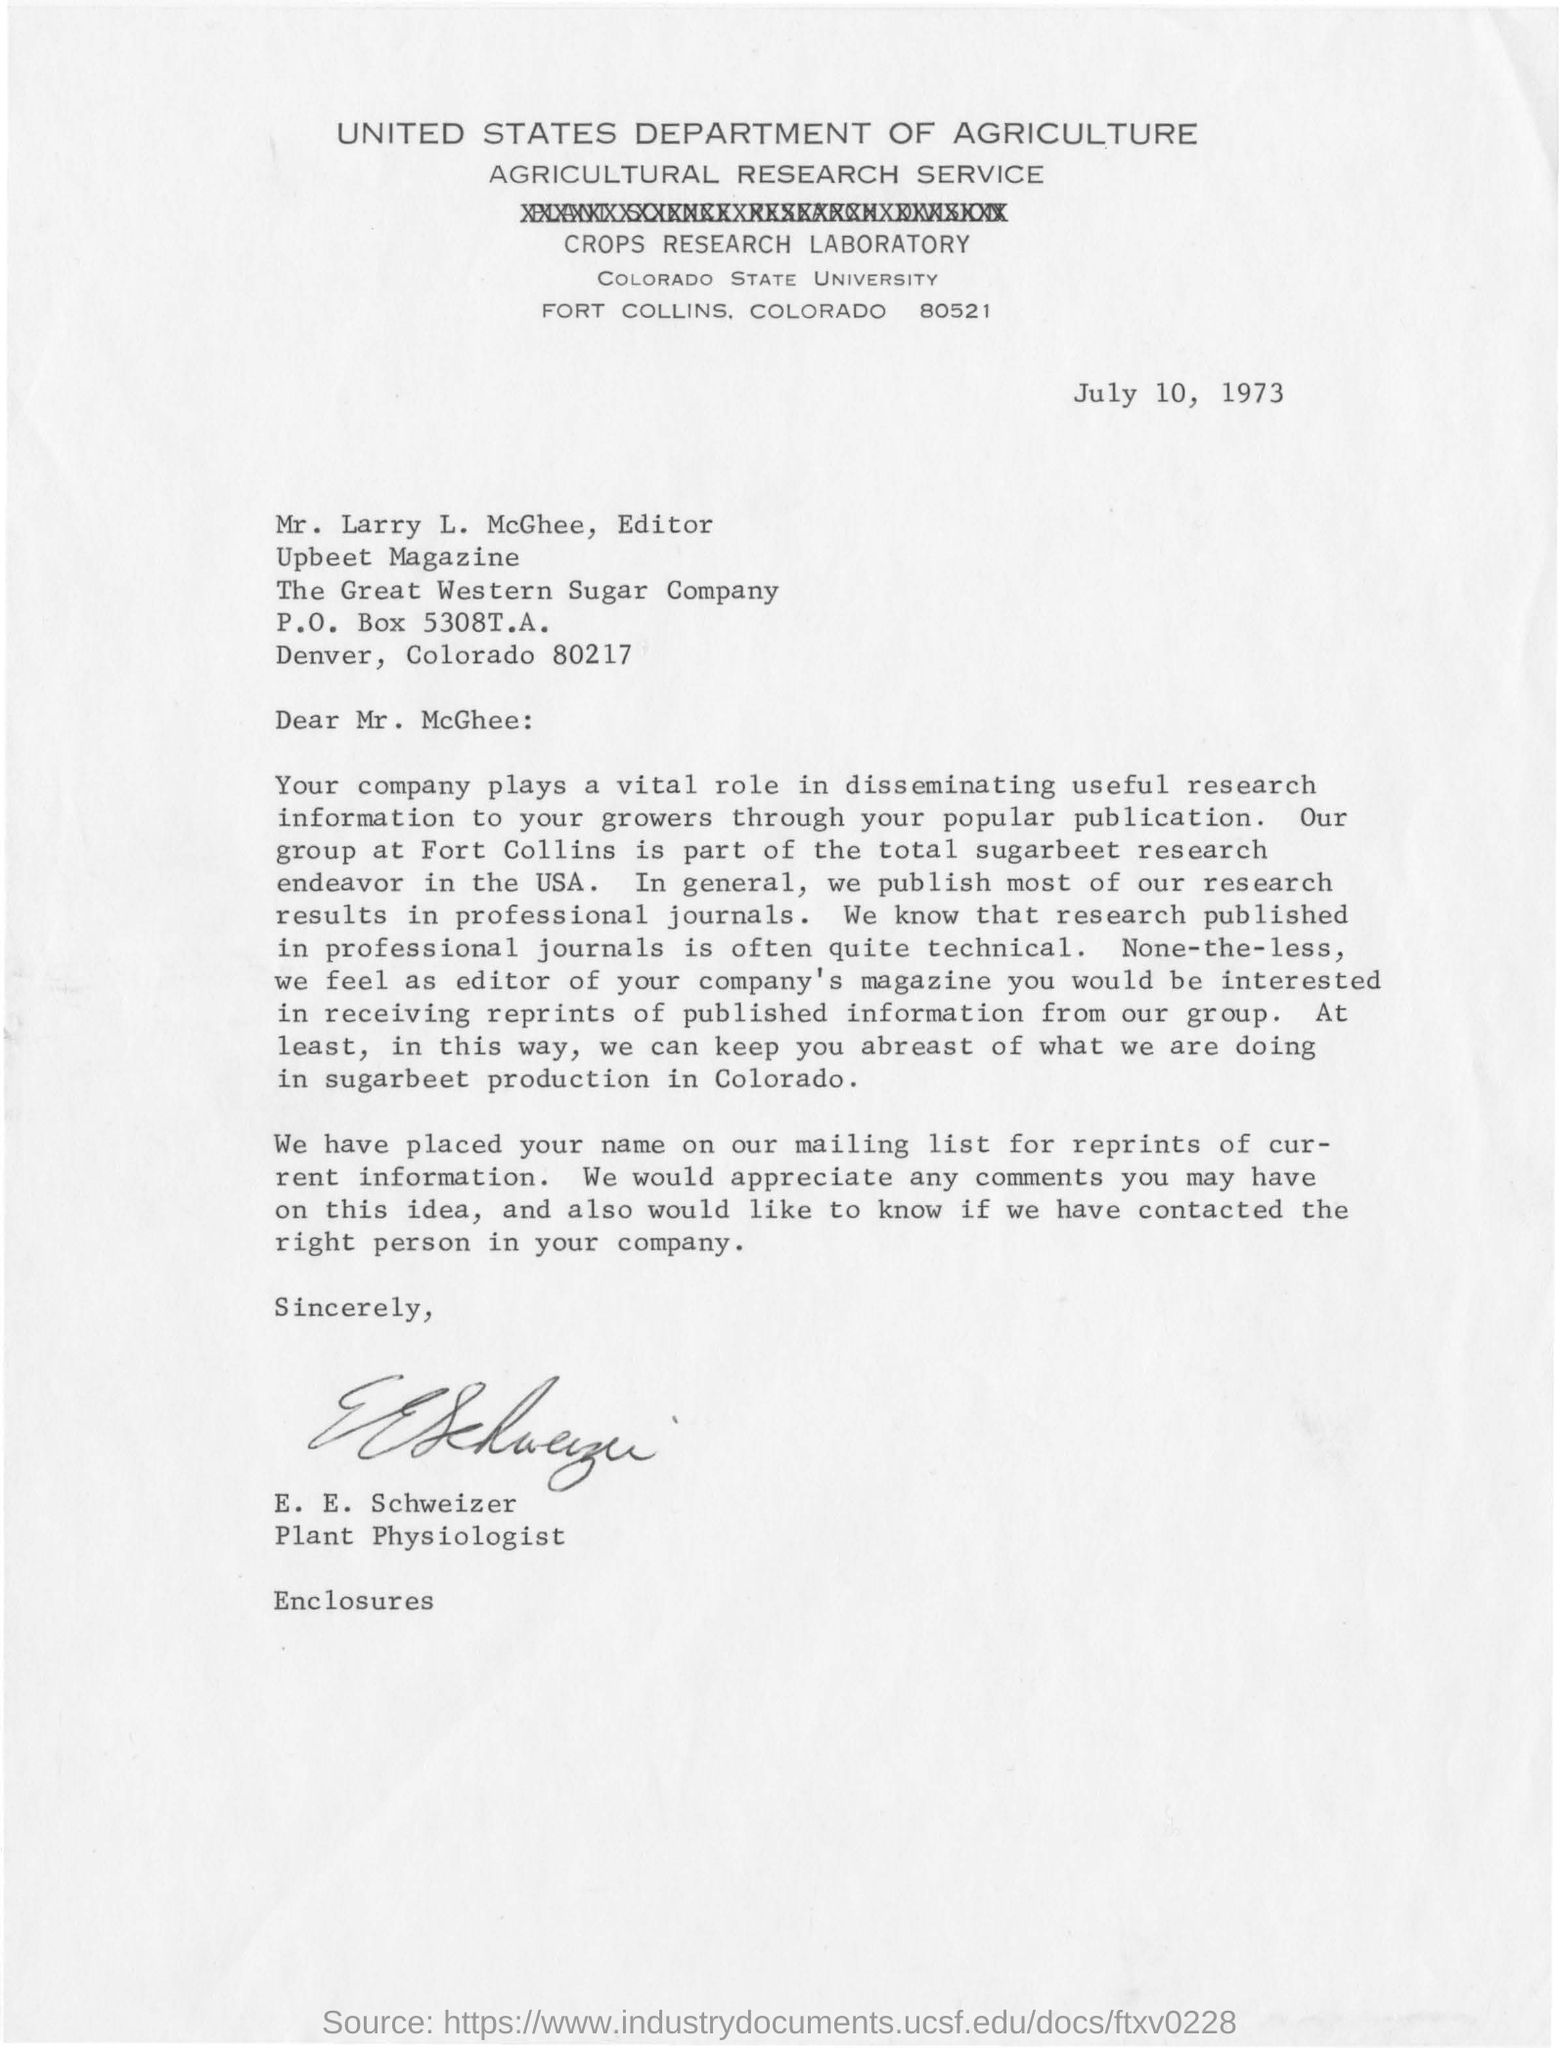Who is the editor of the upbeet magazine ?
Your answer should be compact. Mr. Larry L. McGhee. Which country's department of agriculture is this letter from?
Offer a very short reply. United states department of agriculture. What is the p.o. box number?
Keep it short and to the point. 5308T.A. In which location is  the great western sugar company located?
Offer a terse response. Denver, Colorado 80217. Who is the plant physiologist?
Your response must be concise. E.E. Schweizer. 